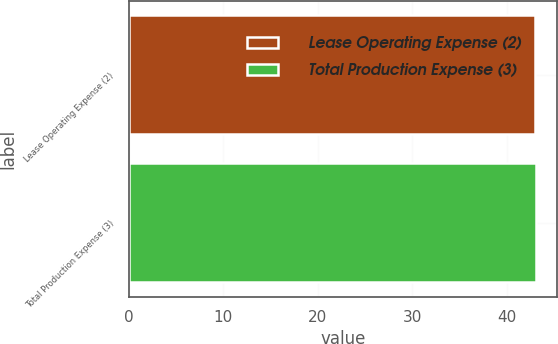<chart> <loc_0><loc_0><loc_500><loc_500><bar_chart><fcel>Lease Operating Expense (2)<fcel>Total Production Expense (3)<nl><fcel>43<fcel>43.1<nl></chart> 